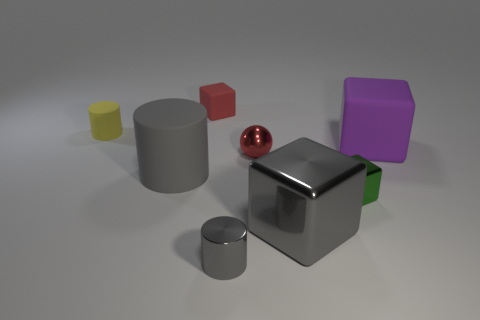Subtract all large gray metal cubes. How many cubes are left? 3 Add 1 blue shiny spheres. How many objects exist? 9 Subtract 1 balls. How many balls are left? 0 Subtract all spheres. How many objects are left? 7 Subtract all yellow cylinders. How many cylinders are left? 2 Subtract all spheres. Subtract all gray cylinders. How many objects are left? 5 Add 1 purple things. How many purple things are left? 2 Add 2 yellow cylinders. How many yellow cylinders exist? 3 Subtract 0 purple cylinders. How many objects are left? 8 Subtract all gray spheres. Subtract all purple cylinders. How many spheres are left? 1 